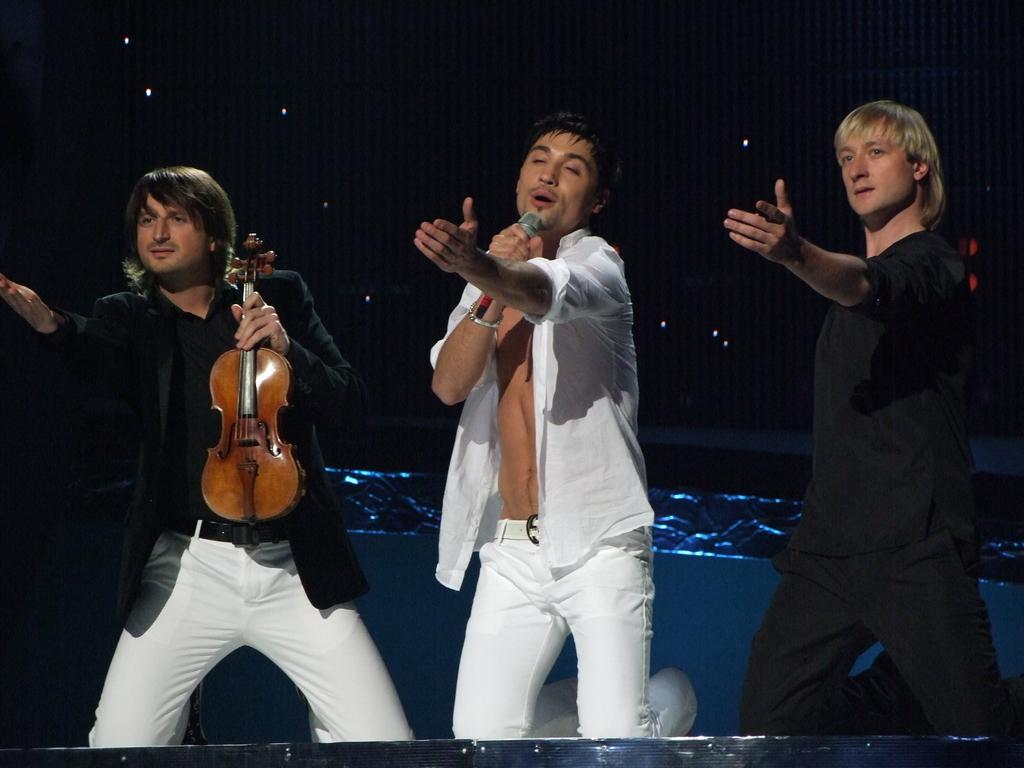How many people are in the image? There are three people in the image. What are the people doing in the image? The people are sitting on their knees. What is the person on the left holding? The person on the left is holding a guitar. What is the person in the center holding? The person in the center is holding a microphone. What can be observed about the person on the right's clothing? The person on the right is wearing a black dress. How many times does the person on the right kick the microphone in the image? There is no indication in the image that the person on the right is kicking the microphone, and therefore no such action can be observed. 